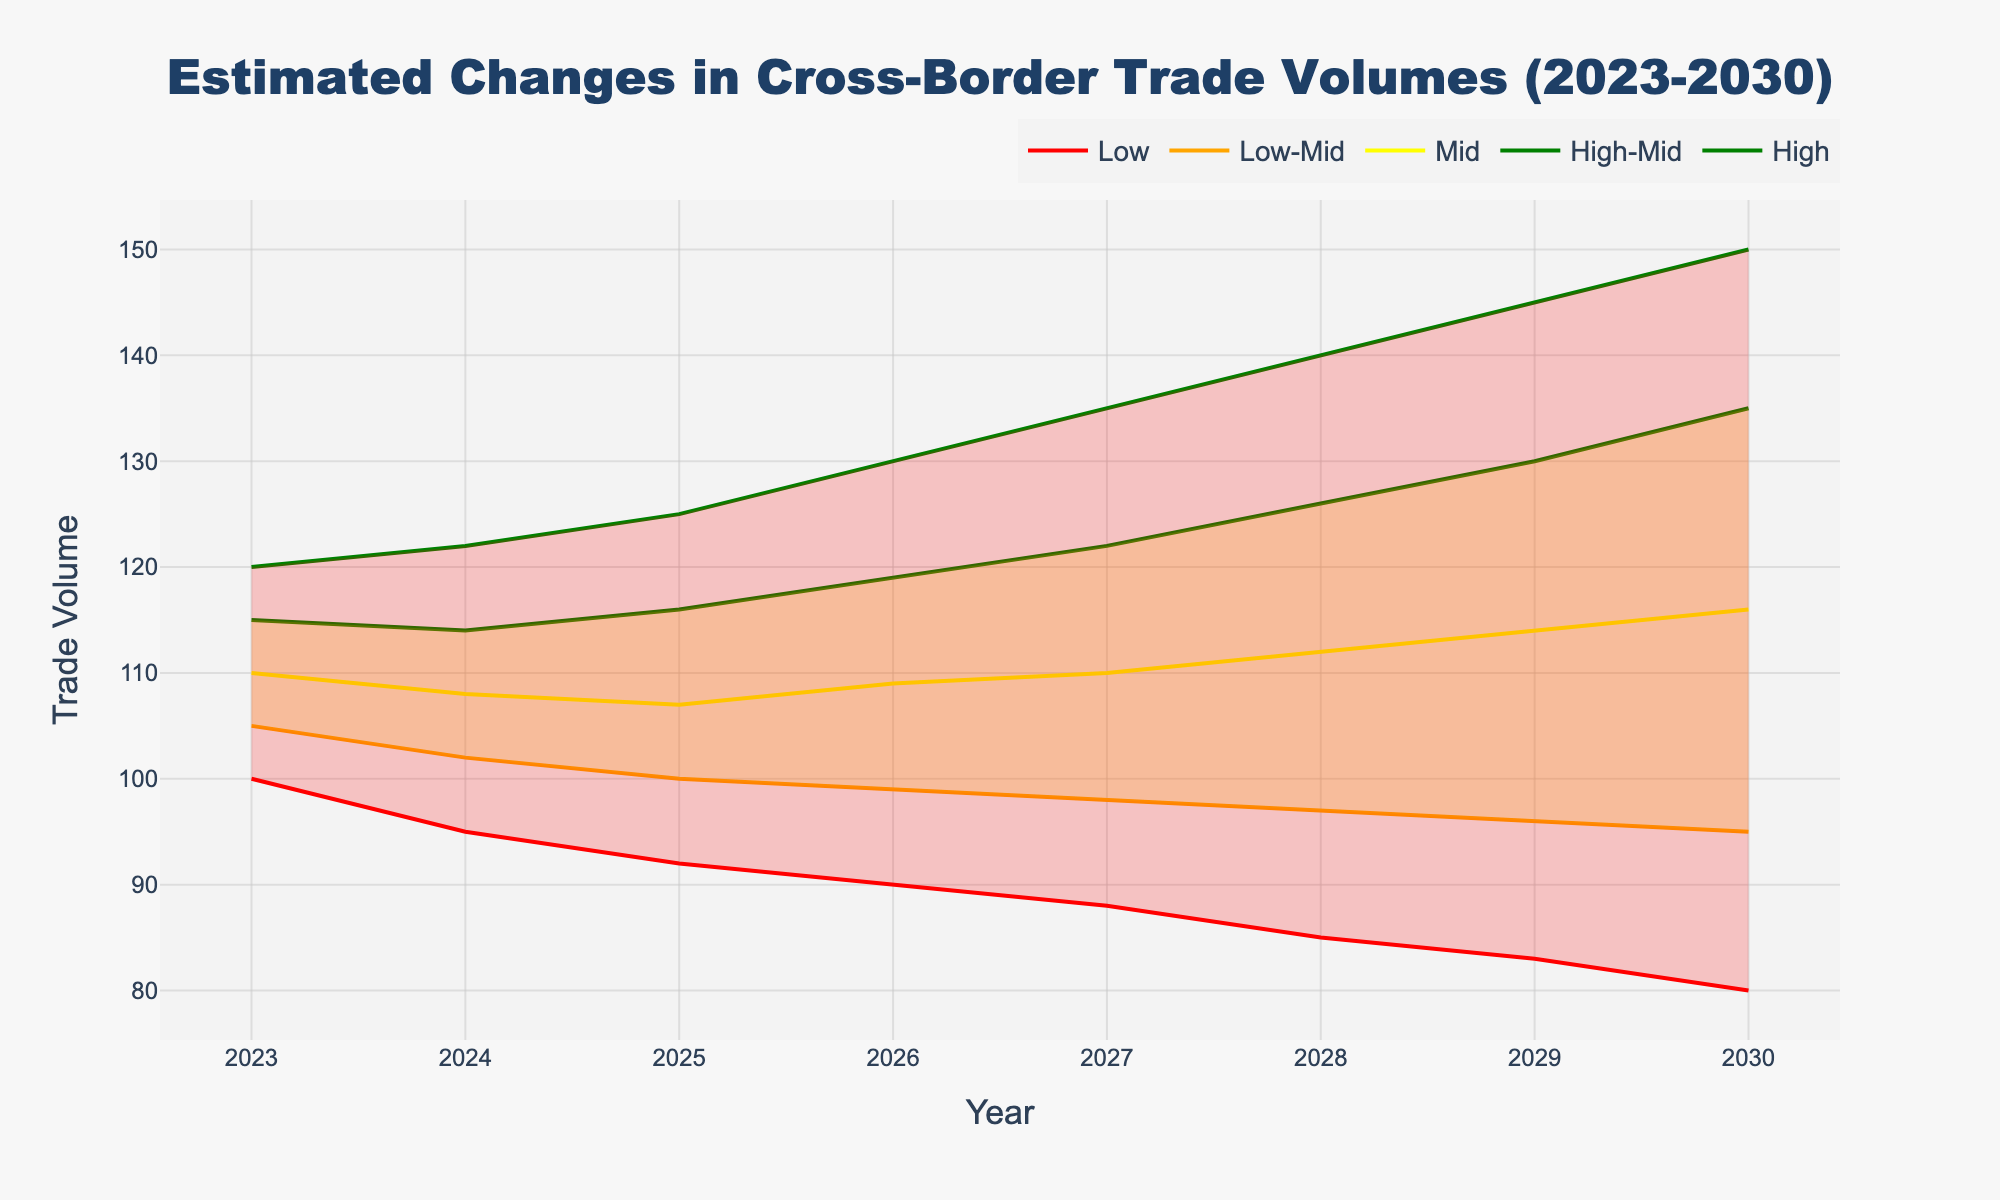What's the title of this plot? The title is displayed at the top center of the plot.
Answer: "Estimated Changes in Cross-Border Trade Volumes (2023-2030)" How does the median estimated trade volume change from 2023 to 2030? Look at the "Mid" series in the plot and observe the values at the two endpoints of the timeline (from 110 in 2023 to 116 in 2030).
Answer: It increases from 110 to 116 Which year shows the lowest high estimate for trade volume? The "High" values are plotted on the figure along each year, and the lowest value within this set is 120 in 2023.
Answer: 2023 By how much does the lowest estimate change from 2023 to 2026? Check the "Low" values for 2023 and 2026, then subtract the value for 2023 (100) from the value for 2026 (90).
Answer: It decreases by 10 What can be inferred about the uncertainty in the estimates over the years? The uncertainty or range between the "Low" and "High" estimates seems to increase over the years. In 2023, the range is 20 (120 - 100), and by 2030, it is 70 (150 - 80).
Answer: The uncertainty generally increases over the years In which year is the median value of the trade volume the highest? Look at the midpoint estimates for all years, and observe that the value at 2030 (116) is the highest among them.
Answer: 2030 Compare the "High-Mid" estimate for 2025 to the "Mid" estimate for 2028. Which one is higher? The "High-Mid" value for 2025 is 116. The "Mid" value for 2028 is 112. 116 is greater than 112.
Answer: "High-Mid" for 2025 How does the spread between high and low estimates in 2024 compare to that in 2029? Calculate the spread for both years. For 2024, it is 122 - 95 = 27. For 2029, it is 145 - 83 = 62. The spread is larger in 2029.
Answer: The spread increases from 27 in 2024 to 62 in 2029 Is there any year where the "Low" estimate is exactly equal to the "Mid" estimate for some other year? Compare "Low" estimates with all "Mid" estimates. The "Low" for 2028 is 85, which matches the "Mid" for 2023.
Answer: Yes, 2028's "Low" matches 2023's "Mid" In which year is the "Low-Mid" estimate closest to the "Mid" estimate? Calculate the difference between each "Low-Mid" and "Mid" value for all the years; the smallest difference appears in 2023:
Answer: 2023 